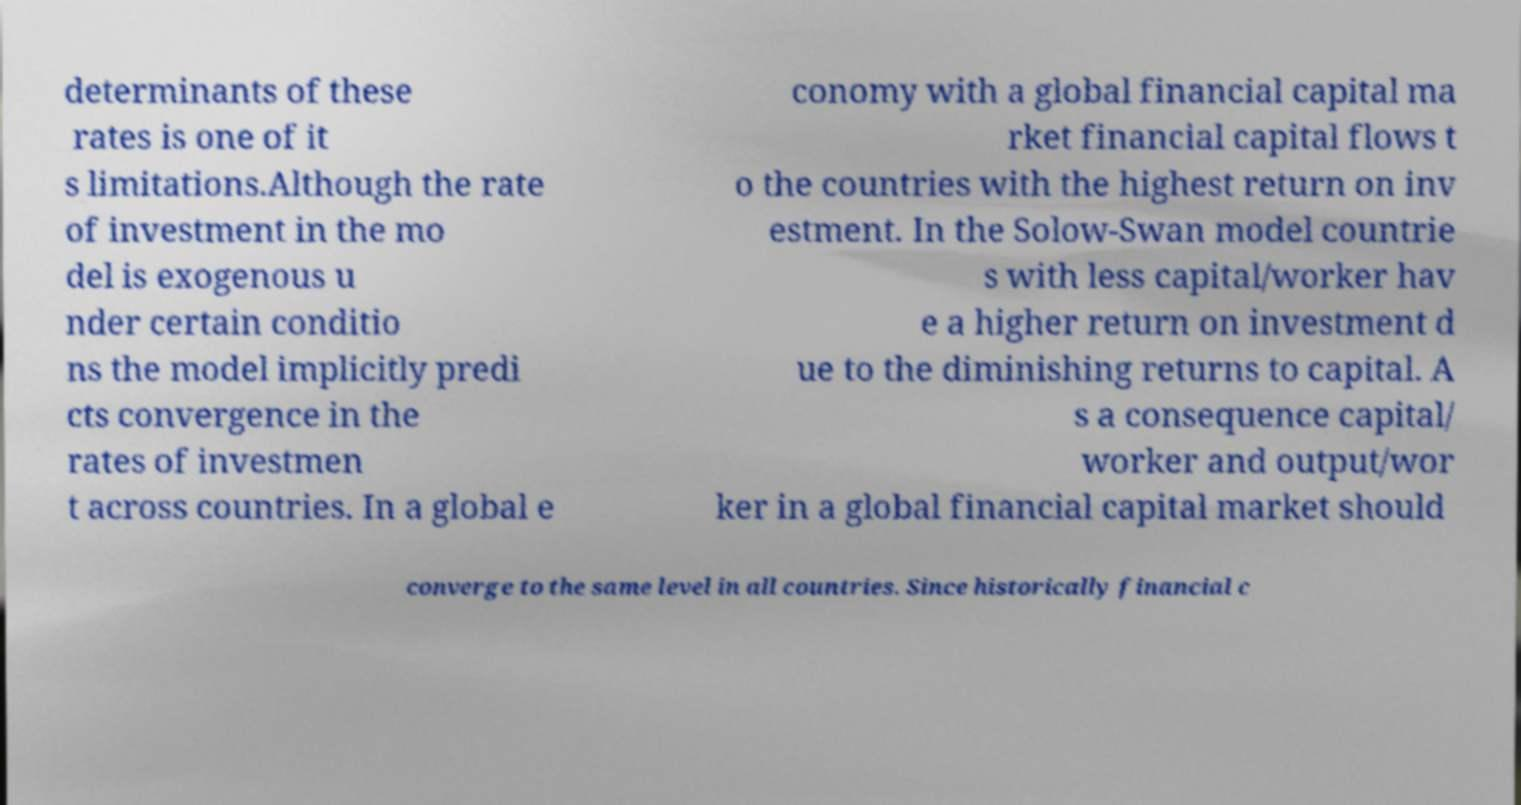There's text embedded in this image that I need extracted. Can you transcribe it verbatim? determinants of these rates is one of it s limitations.Although the rate of investment in the mo del is exogenous u nder certain conditio ns the model implicitly predi cts convergence in the rates of investmen t across countries. In a global e conomy with a global financial capital ma rket financial capital flows t o the countries with the highest return on inv estment. In the Solow-Swan model countrie s with less capital/worker hav e a higher return on investment d ue to the diminishing returns to capital. A s a consequence capital/ worker and output/wor ker in a global financial capital market should converge to the same level in all countries. Since historically financial c 